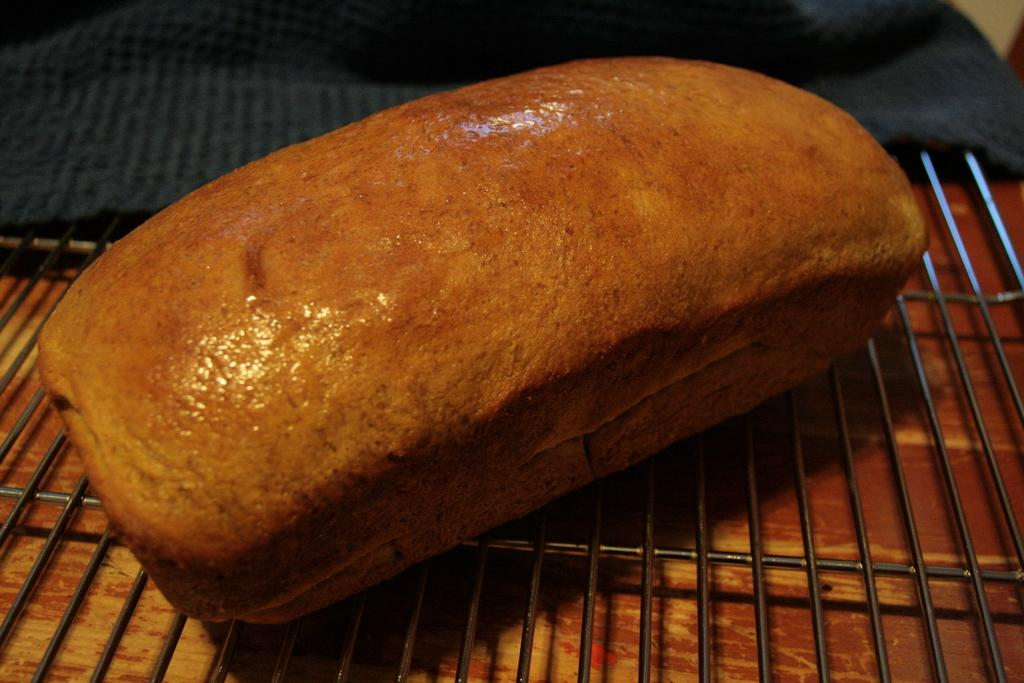What can be seen in the image that is used for cooking food? There is a grill in the image that is used for cooking food. What is on the grill in the image? Food is present on the grill in the image. What is the color of the food on the grill? The food on the grill is brown in color. What other item can be seen in the image besides the grill and food? There is a blue cloth in the image. What type of religion is being practiced in the image? There is no indication of any religious practice in the image; it features a grill with food and a blue cloth. How many cacti are visible in the image? There are no cacti present in the image. 